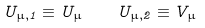Convert formula to latex. <formula><loc_0><loc_0><loc_500><loc_500>U _ { \mu , 1 } \equiv U _ { \mu } \quad U _ { \mu , 2 } \equiv V _ { \mu }</formula> 